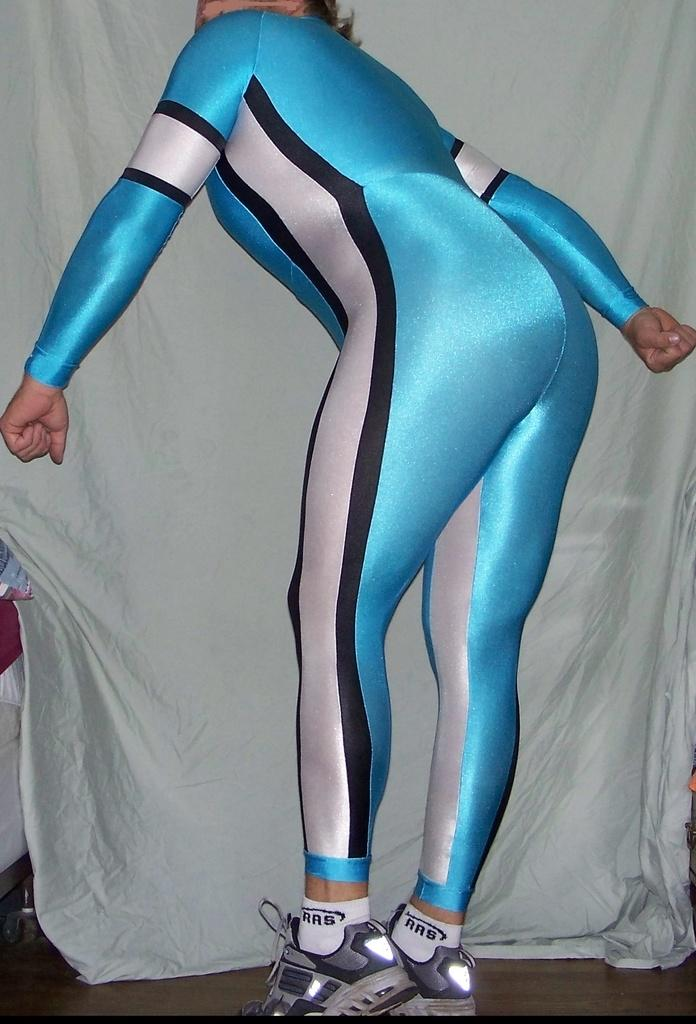<image>
Offer a succinct explanation of the picture presented. A woman bending over in a spandex suit has the letters RRS on her socks. 